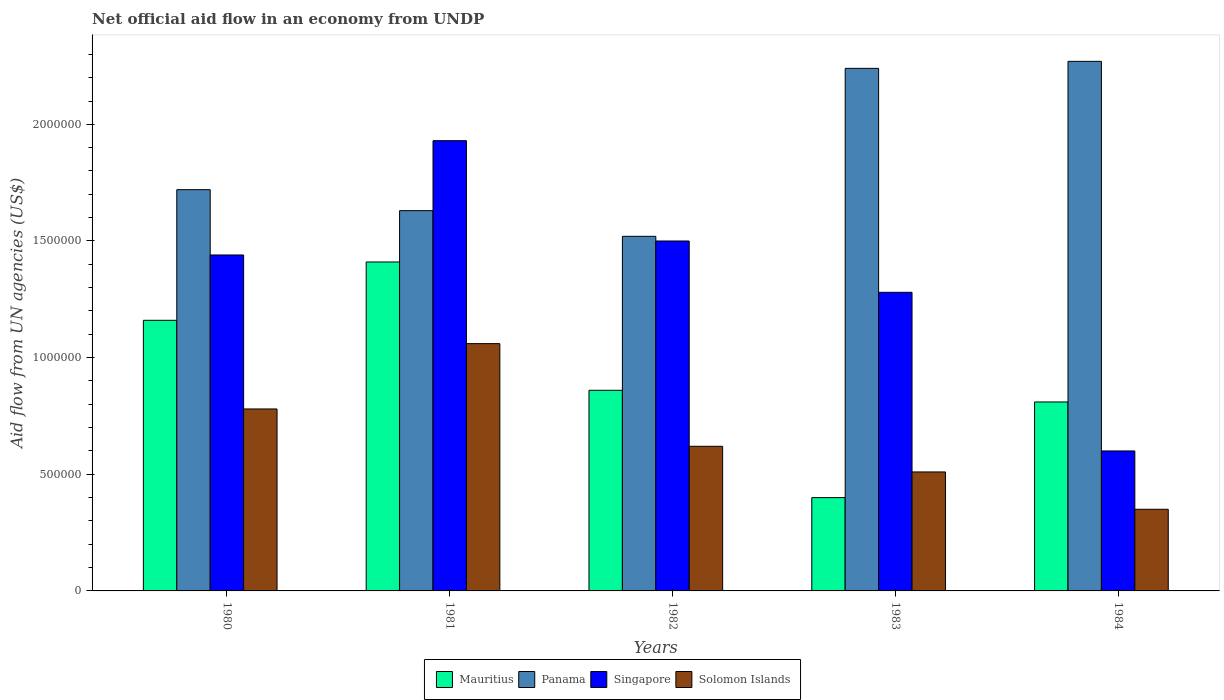How many different coloured bars are there?
Your response must be concise. 4. How many groups of bars are there?
Make the answer very short. 5. Are the number of bars on each tick of the X-axis equal?
Your response must be concise. Yes. How many bars are there on the 3rd tick from the left?
Provide a short and direct response. 4. How many bars are there on the 1st tick from the right?
Your response must be concise. 4. What is the net official aid flow in Mauritius in 1983?
Provide a succinct answer. 4.00e+05. Across all years, what is the maximum net official aid flow in Singapore?
Make the answer very short. 1.93e+06. Across all years, what is the minimum net official aid flow in Solomon Islands?
Provide a short and direct response. 3.50e+05. In which year was the net official aid flow in Solomon Islands minimum?
Provide a succinct answer. 1984. What is the total net official aid flow in Singapore in the graph?
Make the answer very short. 6.75e+06. What is the difference between the net official aid flow in Singapore in 1981 and that in 1983?
Offer a terse response. 6.50e+05. What is the difference between the net official aid flow in Panama in 1982 and the net official aid flow in Solomon Islands in 1984?
Provide a short and direct response. 1.17e+06. What is the average net official aid flow in Solomon Islands per year?
Offer a very short reply. 6.64e+05. In the year 1984, what is the difference between the net official aid flow in Singapore and net official aid flow in Mauritius?
Provide a succinct answer. -2.10e+05. Is the net official aid flow in Solomon Islands in 1980 less than that in 1981?
Offer a terse response. Yes. Is the difference between the net official aid flow in Singapore in 1982 and 1983 greater than the difference between the net official aid flow in Mauritius in 1982 and 1983?
Give a very brief answer. No. What is the difference between the highest and the second highest net official aid flow in Mauritius?
Offer a very short reply. 2.50e+05. What is the difference between the highest and the lowest net official aid flow in Panama?
Your answer should be very brief. 7.50e+05. Is the sum of the net official aid flow in Solomon Islands in 1981 and 1984 greater than the maximum net official aid flow in Singapore across all years?
Offer a very short reply. No. Is it the case that in every year, the sum of the net official aid flow in Singapore and net official aid flow in Mauritius is greater than the sum of net official aid flow in Solomon Islands and net official aid flow in Panama?
Ensure brevity in your answer.  Yes. What does the 2nd bar from the left in 1980 represents?
Make the answer very short. Panama. What does the 2nd bar from the right in 1983 represents?
Offer a terse response. Singapore. Are all the bars in the graph horizontal?
Your answer should be compact. No. How many years are there in the graph?
Keep it short and to the point. 5. Are the values on the major ticks of Y-axis written in scientific E-notation?
Your answer should be compact. No. Does the graph contain any zero values?
Offer a terse response. No. What is the title of the graph?
Offer a very short reply. Net official aid flow in an economy from UNDP. What is the label or title of the Y-axis?
Your response must be concise. Aid flow from UN agencies (US$). What is the Aid flow from UN agencies (US$) in Mauritius in 1980?
Your answer should be compact. 1.16e+06. What is the Aid flow from UN agencies (US$) of Panama in 1980?
Your response must be concise. 1.72e+06. What is the Aid flow from UN agencies (US$) of Singapore in 1980?
Your response must be concise. 1.44e+06. What is the Aid flow from UN agencies (US$) in Solomon Islands in 1980?
Offer a terse response. 7.80e+05. What is the Aid flow from UN agencies (US$) of Mauritius in 1981?
Offer a terse response. 1.41e+06. What is the Aid flow from UN agencies (US$) of Panama in 1981?
Provide a short and direct response. 1.63e+06. What is the Aid flow from UN agencies (US$) of Singapore in 1981?
Offer a terse response. 1.93e+06. What is the Aid flow from UN agencies (US$) of Solomon Islands in 1981?
Offer a very short reply. 1.06e+06. What is the Aid flow from UN agencies (US$) in Mauritius in 1982?
Provide a short and direct response. 8.60e+05. What is the Aid flow from UN agencies (US$) in Panama in 1982?
Your response must be concise. 1.52e+06. What is the Aid flow from UN agencies (US$) of Singapore in 1982?
Keep it short and to the point. 1.50e+06. What is the Aid flow from UN agencies (US$) of Solomon Islands in 1982?
Your response must be concise. 6.20e+05. What is the Aid flow from UN agencies (US$) in Mauritius in 1983?
Provide a succinct answer. 4.00e+05. What is the Aid flow from UN agencies (US$) of Panama in 1983?
Give a very brief answer. 2.24e+06. What is the Aid flow from UN agencies (US$) in Singapore in 1983?
Give a very brief answer. 1.28e+06. What is the Aid flow from UN agencies (US$) in Solomon Islands in 1983?
Make the answer very short. 5.10e+05. What is the Aid flow from UN agencies (US$) of Mauritius in 1984?
Offer a very short reply. 8.10e+05. What is the Aid flow from UN agencies (US$) of Panama in 1984?
Your answer should be compact. 2.27e+06. Across all years, what is the maximum Aid flow from UN agencies (US$) in Mauritius?
Provide a short and direct response. 1.41e+06. Across all years, what is the maximum Aid flow from UN agencies (US$) of Panama?
Ensure brevity in your answer.  2.27e+06. Across all years, what is the maximum Aid flow from UN agencies (US$) in Singapore?
Your answer should be compact. 1.93e+06. Across all years, what is the maximum Aid flow from UN agencies (US$) of Solomon Islands?
Provide a short and direct response. 1.06e+06. Across all years, what is the minimum Aid flow from UN agencies (US$) of Panama?
Keep it short and to the point. 1.52e+06. What is the total Aid flow from UN agencies (US$) in Mauritius in the graph?
Provide a short and direct response. 4.64e+06. What is the total Aid flow from UN agencies (US$) in Panama in the graph?
Provide a succinct answer. 9.38e+06. What is the total Aid flow from UN agencies (US$) in Singapore in the graph?
Your answer should be very brief. 6.75e+06. What is the total Aid flow from UN agencies (US$) in Solomon Islands in the graph?
Make the answer very short. 3.32e+06. What is the difference between the Aid flow from UN agencies (US$) in Panama in 1980 and that in 1981?
Your answer should be compact. 9.00e+04. What is the difference between the Aid flow from UN agencies (US$) of Singapore in 1980 and that in 1981?
Provide a short and direct response. -4.90e+05. What is the difference between the Aid flow from UN agencies (US$) of Solomon Islands in 1980 and that in 1981?
Provide a succinct answer. -2.80e+05. What is the difference between the Aid flow from UN agencies (US$) in Singapore in 1980 and that in 1982?
Your response must be concise. -6.00e+04. What is the difference between the Aid flow from UN agencies (US$) in Mauritius in 1980 and that in 1983?
Offer a terse response. 7.60e+05. What is the difference between the Aid flow from UN agencies (US$) in Panama in 1980 and that in 1983?
Offer a terse response. -5.20e+05. What is the difference between the Aid flow from UN agencies (US$) of Singapore in 1980 and that in 1983?
Offer a very short reply. 1.60e+05. What is the difference between the Aid flow from UN agencies (US$) in Mauritius in 1980 and that in 1984?
Give a very brief answer. 3.50e+05. What is the difference between the Aid flow from UN agencies (US$) of Panama in 1980 and that in 1984?
Give a very brief answer. -5.50e+05. What is the difference between the Aid flow from UN agencies (US$) in Singapore in 1980 and that in 1984?
Make the answer very short. 8.40e+05. What is the difference between the Aid flow from UN agencies (US$) of Panama in 1981 and that in 1982?
Your response must be concise. 1.10e+05. What is the difference between the Aid flow from UN agencies (US$) of Mauritius in 1981 and that in 1983?
Ensure brevity in your answer.  1.01e+06. What is the difference between the Aid flow from UN agencies (US$) of Panama in 1981 and that in 1983?
Provide a succinct answer. -6.10e+05. What is the difference between the Aid flow from UN agencies (US$) in Singapore in 1981 and that in 1983?
Offer a very short reply. 6.50e+05. What is the difference between the Aid flow from UN agencies (US$) of Panama in 1981 and that in 1984?
Your response must be concise. -6.40e+05. What is the difference between the Aid flow from UN agencies (US$) in Singapore in 1981 and that in 1984?
Your answer should be very brief. 1.33e+06. What is the difference between the Aid flow from UN agencies (US$) in Solomon Islands in 1981 and that in 1984?
Your answer should be very brief. 7.10e+05. What is the difference between the Aid flow from UN agencies (US$) in Panama in 1982 and that in 1983?
Your answer should be very brief. -7.20e+05. What is the difference between the Aid flow from UN agencies (US$) in Solomon Islands in 1982 and that in 1983?
Make the answer very short. 1.10e+05. What is the difference between the Aid flow from UN agencies (US$) of Panama in 1982 and that in 1984?
Provide a succinct answer. -7.50e+05. What is the difference between the Aid flow from UN agencies (US$) of Mauritius in 1983 and that in 1984?
Offer a terse response. -4.10e+05. What is the difference between the Aid flow from UN agencies (US$) in Singapore in 1983 and that in 1984?
Make the answer very short. 6.80e+05. What is the difference between the Aid flow from UN agencies (US$) in Mauritius in 1980 and the Aid flow from UN agencies (US$) in Panama in 1981?
Your answer should be very brief. -4.70e+05. What is the difference between the Aid flow from UN agencies (US$) in Mauritius in 1980 and the Aid flow from UN agencies (US$) in Singapore in 1981?
Your response must be concise. -7.70e+05. What is the difference between the Aid flow from UN agencies (US$) of Panama in 1980 and the Aid flow from UN agencies (US$) of Singapore in 1981?
Offer a terse response. -2.10e+05. What is the difference between the Aid flow from UN agencies (US$) of Panama in 1980 and the Aid flow from UN agencies (US$) of Solomon Islands in 1981?
Offer a very short reply. 6.60e+05. What is the difference between the Aid flow from UN agencies (US$) of Mauritius in 1980 and the Aid flow from UN agencies (US$) of Panama in 1982?
Ensure brevity in your answer.  -3.60e+05. What is the difference between the Aid flow from UN agencies (US$) of Mauritius in 1980 and the Aid flow from UN agencies (US$) of Singapore in 1982?
Provide a short and direct response. -3.40e+05. What is the difference between the Aid flow from UN agencies (US$) of Mauritius in 1980 and the Aid flow from UN agencies (US$) of Solomon Islands in 1982?
Provide a short and direct response. 5.40e+05. What is the difference between the Aid flow from UN agencies (US$) in Panama in 1980 and the Aid flow from UN agencies (US$) in Solomon Islands in 1982?
Your response must be concise. 1.10e+06. What is the difference between the Aid flow from UN agencies (US$) of Singapore in 1980 and the Aid flow from UN agencies (US$) of Solomon Islands in 1982?
Give a very brief answer. 8.20e+05. What is the difference between the Aid flow from UN agencies (US$) of Mauritius in 1980 and the Aid flow from UN agencies (US$) of Panama in 1983?
Offer a very short reply. -1.08e+06. What is the difference between the Aid flow from UN agencies (US$) in Mauritius in 1980 and the Aid flow from UN agencies (US$) in Solomon Islands in 1983?
Your answer should be compact. 6.50e+05. What is the difference between the Aid flow from UN agencies (US$) of Panama in 1980 and the Aid flow from UN agencies (US$) of Solomon Islands in 1983?
Your response must be concise. 1.21e+06. What is the difference between the Aid flow from UN agencies (US$) of Singapore in 1980 and the Aid flow from UN agencies (US$) of Solomon Islands in 1983?
Your answer should be compact. 9.30e+05. What is the difference between the Aid flow from UN agencies (US$) of Mauritius in 1980 and the Aid flow from UN agencies (US$) of Panama in 1984?
Ensure brevity in your answer.  -1.11e+06. What is the difference between the Aid flow from UN agencies (US$) in Mauritius in 1980 and the Aid flow from UN agencies (US$) in Singapore in 1984?
Offer a terse response. 5.60e+05. What is the difference between the Aid flow from UN agencies (US$) in Mauritius in 1980 and the Aid flow from UN agencies (US$) in Solomon Islands in 1984?
Offer a very short reply. 8.10e+05. What is the difference between the Aid flow from UN agencies (US$) in Panama in 1980 and the Aid flow from UN agencies (US$) in Singapore in 1984?
Provide a short and direct response. 1.12e+06. What is the difference between the Aid flow from UN agencies (US$) in Panama in 1980 and the Aid flow from UN agencies (US$) in Solomon Islands in 1984?
Ensure brevity in your answer.  1.37e+06. What is the difference between the Aid flow from UN agencies (US$) of Singapore in 1980 and the Aid flow from UN agencies (US$) of Solomon Islands in 1984?
Offer a very short reply. 1.09e+06. What is the difference between the Aid flow from UN agencies (US$) of Mauritius in 1981 and the Aid flow from UN agencies (US$) of Solomon Islands in 1982?
Provide a succinct answer. 7.90e+05. What is the difference between the Aid flow from UN agencies (US$) in Panama in 1981 and the Aid flow from UN agencies (US$) in Singapore in 1982?
Offer a very short reply. 1.30e+05. What is the difference between the Aid flow from UN agencies (US$) in Panama in 1981 and the Aid flow from UN agencies (US$) in Solomon Islands in 1982?
Ensure brevity in your answer.  1.01e+06. What is the difference between the Aid flow from UN agencies (US$) of Singapore in 1981 and the Aid flow from UN agencies (US$) of Solomon Islands in 1982?
Offer a very short reply. 1.31e+06. What is the difference between the Aid flow from UN agencies (US$) in Mauritius in 1981 and the Aid flow from UN agencies (US$) in Panama in 1983?
Provide a short and direct response. -8.30e+05. What is the difference between the Aid flow from UN agencies (US$) in Mauritius in 1981 and the Aid flow from UN agencies (US$) in Singapore in 1983?
Make the answer very short. 1.30e+05. What is the difference between the Aid flow from UN agencies (US$) in Mauritius in 1981 and the Aid flow from UN agencies (US$) in Solomon Islands in 1983?
Your response must be concise. 9.00e+05. What is the difference between the Aid flow from UN agencies (US$) in Panama in 1981 and the Aid flow from UN agencies (US$) in Singapore in 1983?
Your response must be concise. 3.50e+05. What is the difference between the Aid flow from UN agencies (US$) in Panama in 1981 and the Aid flow from UN agencies (US$) in Solomon Islands in 1983?
Ensure brevity in your answer.  1.12e+06. What is the difference between the Aid flow from UN agencies (US$) of Singapore in 1981 and the Aid flow from UN agencies (US$) of Solomon Islands in 1983?
Keep it short and to the point. 1.42e+06. What is the difference between the Aid flow from UN agencies (US$) of Mauritius in 1981 and the Aid flow from UN agencies (US$) of Panama in 1984?
Provide a succinct answer. -8.60e+05. What is the difference between the Aid flow from UN agencies (US$) of Mauritius in 1981 and the Aid flow from UN agencies (US$) of Singapore in 1984?
Give a very brief answer. 8.10e+05. What is the difference between the Aid flow from UN agencies (US$) in Mauritius in 1981 and the Aid flow from UN agencies (US$) in Solomon Islands in 1984?
Provide a succinct answer. 1.06e+06. What is the difference between the Aid flow from UN agencies (US$) in Panama in 1981 and the Aid flow from UN agencies (US$) in Singapore in 1984?
Keep it short and to the point. 1.03e+06. What is the difference between the Aid flow from UN agencies (US$) in Panama in 1981 and the Aid flow from UN agencies (US$) in Solomon Islands in 1984?
Your response must be concise. 1.28e+06. What is the difference between the Aid flow from UN agencies (US$) of Singapore in 1981 and the Aid flow from UN agencies (US$) of Solomon Islands in 1984?
Your answer should be very brief. 1.58e+06. What is the difference between the Aid flow from UN agencies (US$) in Mauritius in 1982 and the Aid flow from UN agencies (US$) in Panama in 1983?
Provide a short and direct response. -1.38e+06. What is the difference between the Aid flow from UN agencies (US$) in Mauritius in 1982 and the Aid flow from UN agencies (US$) in Singapore in 1983?
Your answer should be compact. -4.20e+05. What is the difference between the Aid flow from UN agencies (US$) in Panama in 1982 and the Aid flow from UN agencies (US$) in Solomon Islands in 1983?
Your answer should be very brief. 1.01e+06. What is the difference between the Aid flow from UN agencies (US$) in Singapore in 1982 and the Aid flow from UN agencies (US$) in Solomon Islands in 1983?
Your answer should be compact. 9.90e+05. What is the difference between the Aid flow from UN agencies (US$) in Mauritius in 1982 and the Aid flow from UN agencies (US$) in Panama in 1984?
Provide a succinct answer. -1.41e+06. What is the difference between the Aid flow from UN agencies (US$) in Mauritius in 1982 and the Aid flow from UN agencies (US$) in Solomon Islands in 1984?
Ensure brevity in your answer.  5.10e+05. What is the difference between the Aid flow from UN agencies (US$) of Panama in 1982 and the Aid flow from UN agencies (US$) of Singapore in 1984?
Offer a terse response. 9.20e+05. What is the difference between the Aid flow from UN agencies (US$) of Panama in 1982 and the Aid flow from UN agencies (US$) of Solomon Islands in 1984?
Your answer should be compact. 1.17e+06. What is the difference between the Aid flow from UN agencies (US$) in Singapore in 1982 and the Aid flow from UN agencies (US$) in Solomon Islands in 1984?
Your response must be concise. 1.15e+06. What is the difference between the Aid flow from UN agencies (US$) in Mauritius in 1983 and the Aid flow from UN agencies (US$) in Panama in 1984?
Make the answer very short. -1.87e+06. What is the difference between the Aid flow from UN agencies (US$) in Mauritius in 1983 and the Aid flow from UN agencies (US$) in Singapore in 1984?
Your answer should be very brief. -2.00e+05. What is the difference between the Aid flow from UN agencies (US$) in Mauritius in 1983 and the Aid flow from UN agencies (US$) in Solomon Islands in 1984?
Provide a succinct answer. 5.00e+04. What is the difference between the Aid flow from UN agencies (US$) in Panama in 1983 and the Aid flow from UN agencies (US$) in Singapore in 1984?
Provide a short and direct response. 1.64e+06. What is the difference between the Aid flow from UN agencies (US$) of Panama in 1983 and the Aid flow from UN agencies (US$) of Solomon Islands in 1984?
Offer a terse response. 1.89e+06. What is the difference between the Aid flow from UN agencies (US$) of Singapore in 1983 and the Aid flow from UN agencies (US$) of Solomon Islands in 1984?
Your answer should be compact. 9.30e+05. What is the average Aid flow from UN agencies (US$) of Mauritius per year?
Offer a terse response. 9.28e+05. What is the average Aid flow from UN agencies (US$) of Panama per year?
Provide a succinct answer. 1.88e+06. What is the average Aid flow from UN agencies (US$) of Singapore per year?
Your answer should be very brief. 1.35e+06. What is the average Aid flow from UN agencies (US$) of Solomon Islands per year?
Your response must be concise. 6.64e+05. In the year 1980, what is the difference between the Aid flow from UN agencies (US$) in Mauritius and Aid flow from UN agencies (US$) in Panama?
Provide a short and direct response. -5.60e+05. In the year 1980, what is the difference between the Aid flow from UN agencies (US$) of Mauritius and Aid flow from UN agencies (US$) of Singapore?
Keep it short and to the point. -2.80e+05. In the year 1980, what is the difference between the Aid flow from UN agencies (US$) of Panama and Aid flow from UN agencies (US$) of Singapore?
Your response must be concise. 2.80e+05. In the year 1980, what is the difference between the Aid flow from UN agencies (US$) in Panama and Aid flow from UN agencies (US$) in Solomon Islands?
Your answer should be very brief. 9.40e+05. In the year 1981, what is the difference between the Aid flow from UN agencies (US$) of Mauritius and Aid flow from UN agencies (US$) of Singapore?
Keep it short and to the point. -5.20e+05. In the year 1981, what is the difference between the Aid flow from UN agencies (US$) in Panama and Aid flow from UN agencies (US$) in Solomon Islands?
Make the answer very short. 5.70e+05. In the year 1981, what is the difference between the Aid flow from UN agencies (US$) of Singapore and Aid flow from UN agencies (US$) of Solomon Islands?
Your answer should be compact. 8.70e+05. In the year 1982, what is the difference between the Aid flow from UN agencies (US$) of Mauritius and Aid flow from UN agencies (US$) of Panama?
Your response must be concise. -6.60e+05. In the year 1982, what is the difference between the Aid flow from UN agencies (US$) in Mauritius and Aid flow from UN agencies (US$) in Singapore?
Ensure brevity in your answer.  -6.40e+05. In the year 1982, what is the difference between the Aid flow from UN agencies (US$) in Panama and Aid flow from UN agencies (US$) in Solomon Islands?
Make the answer very short. 9.00e+05. In the year 1982, what is the difference between the Aid flow from UN agencies (US$) of Singapore and Aid flow from UN agencies (US$) of Solomon Islands?
Your response must be concise. 8.80e+05. In the year 1983, what is the difference between the Aid flow from UN agencies (US$) of Mauritius and Aid flow from UN agencies (US$) of Panama?
Make the answer very short. -1.84e+06. In the year 1983, what is the difference between the Aid flow from UN agencies (US$) of Mauritius and Aid flow from UN agencies (US$) of Singapore?
Offer a very short reply. -8.80e+05. In the year 1983, what is the difference between the Aid flow from UN agencies (US$) in Panama and Aid flow from UN agencies (US$) in Singapore?
Give a very brief answer. 9.60e+05. In the year 1983, what is the difference between the Aid flow from UN agencies (US$) of Panama and Aid flow from UN agencies (US$) of Solomon Islands?
Give a very brief answer. 1.73e+06. In the year 1983, what is the difference between the Aid flow from UN agencies (US$) of Singapore and Aid flow from UN agencies (US$) of Solomon Islands?
Offer a very short reply. 7.70e+05. In the year 1984, what is the difference between the Aid flow from UN agencies (US$) of Mauritius and Aid flow from UN agencies (US$) of Panama?
Your answer should be very brief. -1.46e+06. In the year 1984, what is the difference between the Aid flow from UN agencies (US$) of Mauritius and Aid flow from UN agencies (US$) of Singapore?
Make the answer very short. 2.10e+05. In the year 1984, what is the difference between the Aid flow from UN agencies (US$) in Panama and Aid flow from UN agencies (US$) in Singapore?
Your answer should be very brief. 1.67e+06. In the year 1984, what is the difference between the Aid flow from UN agencies (US$) in Panama and Aid flow from UN agencies (US$) in Solomon Islands?
Provide a succinct answer. 1.92e+06. In the year 1984, what is the difference between the Aid flow from UN agencies (US$) of Singapore and Aid flow from UN agencies (US$) of Solomon Islands?
Your answer should be compact. 2.50e+05. What is the ratio of the Aid flow from UN agencies (US$) in Mauritius in 1980 to that in 1981?
Make the answer very short. 0.82. What is the ratio of the Aid flow from UN agencies (US$) in Panama in 1980 to that in 1981?
Your answer should be compact. 1.06. What is the ratio of the Aid flow from UN agencies (US$) of Singapore in 1980 to that in 1981?
Ensure brevity in your answer.  0.75. What is the ratio of the Aid flow from UN agencies (US$) in Solomon Islands in 1980 to that in 1981?
Make the answer very short. 0.74. What is the ratio of the Aid flow from UN agencies (US$) of Mauritius in 1980 to that in 1982?
Offer a very short reply. 1.35. What is the ratio of the Aid flow from UN agencies (US$) of Panama in 1980 to that in 1982?
Make the answer very short. 1.13. What is the ratio of the Aid flow from UN agencies (US$) in Singapore in 1980 to that in 1982?
Make the answer very short. 0.96. What is the ratio of the Aid flow from UN agencies (US$) of Solomon Islands in 1980 to that in 1982?
Keep it short and to the point. 1.26. What is the ratio of the Aid flow from UN agencies (US$) of Mauritius in 1980 to that in 1983?
Your response must be concise. 2.9. What is the ratio of the Aid flow from UN agencies (US$) of Panama in 1980 to that in 1983?
Your answer should be compact. 0.77. What is the ratio of the Aid flow from UN agencies (US$) in Solomon Islands in 1980 to that in 1983?
Provide a succinct answer. 1.53. What is the ratio of the Aid flow from UN agencies (US$) in Mauritius in 1980 to that in 1984?
Make the answer very short. 1.43. What is the ratio of the Aid flow from UN agencies (US$) in Panama in 1980 to that in 1984?
Offer a terse response. 0.76. What is the ratio of the Aid flow from UN agencies (US$) of Singapore in 1980 to that in 1984?
Your answer should be very brief. 2.4. What is the ratio of the Aid flow from UN agencies (US$) of Solomon Islands in 1980 to that in 1984?
Provide a short and direct response. 2.23. What is the ratio of the Aid flow from UN agencies (US$) of Mauritius in 1981 to that in 1982?
Your response must be concise. 1.64. What is the ratio of the Aid flow from UN agencies (US$) in Panama in 1981 to that in 1982?
Give a very brief answer. 1.07. What is the ratio of the Aid flow from UN agencies (US$) in Singapore in 1981 to that in 1982?
Your response must be concise. 1.29. What is the ratio of the Aid flow from UN agencies (US$) of Solomon Islands in 1981 to that in 1982?
Your answer should be compact. 1.71. What is the ratio of the Aid flow from UN agencies (US$) of Mauritius in 1981 to that in 1983?
Your answer should be very brief. 3.52. What is the ratio of the Aid flow from UN agencies (US$) of Panama in 1981 to that in 1983?
Offer a terse response. 0.73. What is the ratio of the Aid flow from UN agencies (US$) in Singapore in 1981 to that in 1983?
Ensure brevity in your answer.  1.51. What is the ratio of the Aid flow from UN agencies (US$) of Solomon Islands in 1981 to that in 1983?
Make the answer very short. 2.08. What is the ratio of the Aid flow from UN agencies (US$) of Mauritius in 1981 to that in 1984?
Offer a terse response. 1.74. What is the ratio of the Aid flow from UN agencies (US$) in Panama in 1981 to that in 1984?
Make the answer very short. 0.72. What is the ratio of the Aid flow from UN agencies (US$) of Singapore in 1981 to that in 1984?
Your response must be concise. 3.22. What is the ratio of the Aid flow from UN agencies (US$) of Solomon Islands in 1981 to that in 1984?
Keep it short and to the point. 3.03. What is the ratio of the Aid flow from UN agencies (US$) in Mauritius in 1982 to that in 1983?
Provide a succinct answer. 2.15. What is the ratio of the Aid flow from UN agencies (US$) in Panama in 1982 to that in 1983?
Ensure brevity in your answer.  0.68. What is the ratio of the Aid flow from UN agencies (US$) in Singapore in 1982 to that in 1983?
Give a very brief answer. 1.17. What is the ratio of the Aid flow from UN agencies (US$) of Solomon Islands in 1982 to that in 1983?
Make the answer very short. 1.22. What is the ratio of the Aid flow from UN agencies (US$) of Mauritius in 1982 to that in 1984?
Your answer should be compact. 1.06. What is the ratio of the Aid flow from UN agencies (US$) in Panama in 1982 to that in 1984?
Keep it short and to the point. 0.67. What is the ratio of the Aid flow from UN agencies (US$) in Solomon Islands in 1982 to that in 1984?
Offer a very short reply. 1.77. What is the ratio of the Aid flow from UN agencies (US$) of Mauritius in 1983 to that in 1984?
Keep it short and to the point. 0.49. What is the ratio of the Aid flow from UN agencies (US$) in Panama in 1983 to that in 1984?
Offer a very short reply. 0.99. What is the ratio of the Aid flow from UN agencies (US$) in Singapore in 1983 to that in 1984?
Give a very brief answer. 2.13. What is the ratio of the Aid flow from UN agencies (US$) in Solomon Islands in 1983 to that in 1984?
Give a very brief answer. 1.46. What is the difference between the highest and the second highest Aid flow from UN agencies (US$) in Mauritius?
Ensure brevity in your answer.  2.50e+05. What is the difference between the highest and the second highest Aid flow from UN agencies (US$) in Panama?
Ensure brevity in your answer.  3.00e+04. What is the difference between the highest and the second highest Aid flow from UN agencies (US$) in Singapore?
Give a very brief answer. 4.30e+05. What is the difference between the highest and the lowest Aid flow from UN agencies (US$) in Mauritius?
Your answer should be very brief. 1.01e+06. What is the difference between the highest and the lowest Aid flow from UN agencies (US$) of Panama?
Your answer should be very brief. 7.50e+05. What is the difference between the highest and the lowest Aid flow from UN agencies (US$) in Singapore?
Give a very brief answer. 1.33e+06. What is the difference between the highest and the lowest Aid flow from UN agencies (US$) of Solomon Islands?
Offer a terse response. 7.10e+05. 